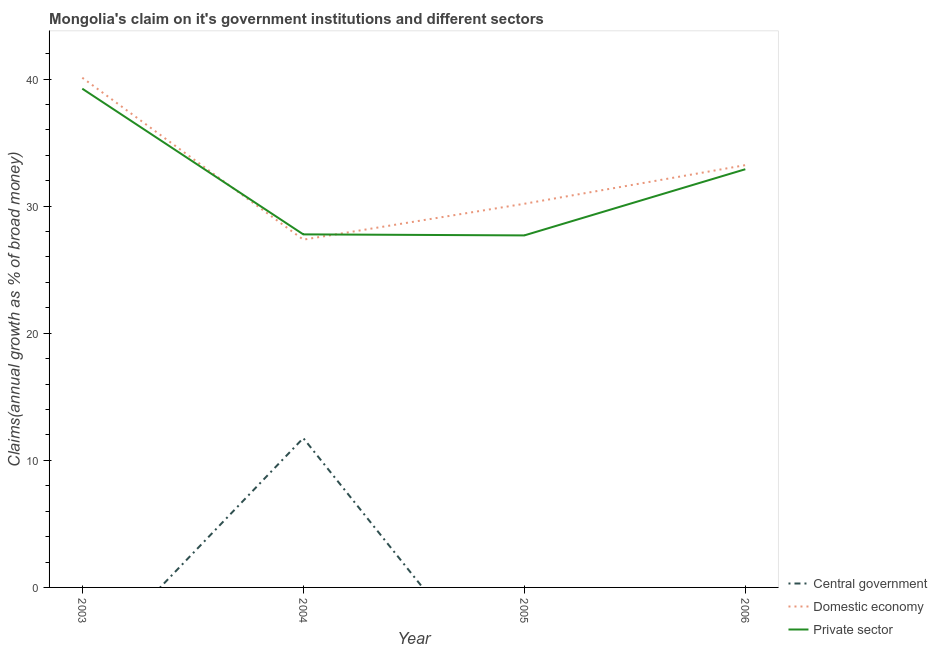Does the line corresponding to percentage of claim on the private sector intersect with the line corresponding to percentage of claim on the central government?
Offer a very short reply. No. What is the percentage of claim on the private sector in 2005?
Your response must be concise. 27.69. Across all years, what is the maximum percentage of claim on the central government?
Keep it short and to the point. 11.75. Across all years, what is the minimum percentage of claim on the private sector?
Give a very brief answer. 27.69. In which year was the percentage of claim on the private sector maximum?
Keep it short and to the point. 2003. What is the total percentage of claim on the private sector in the graph?
Offer a terse response. 127.61. What is the difference between the percentage of claim on the private sector in 2003 and that in 2006?
Provide a succinct answer. 6.34. What is the difference between the percentage of claim on the central government in 2004 and the percentage of claim on the domestic economy in 2003?
Make the answer very short. -28.35. What is the average percentage of claim on the central government per year?
Offer a very short reply. 2.94. In the year 2004, what is the difference between the percentage of claim on the domestic economy and percentage of claim on the private sector?
Your response must be concise. -0.41. In how many years, is the percentage of claim on the central government greater than 34 %?
Offer a terse response. 0. What is the ratio of the percentage of claim on the domestic economy in 2003 to that in 2006?
Your answer should be very brief. 1.21. What is the difference between the highest and the second highest percentage of claim on the private sector?
Your answer should be compact. 6.34. What is the difference between the highest and the lowest percentage of claim on the domestic economy?
Provide a succinct answer. 12.74. Is the percentage of claim on the domestic economy strictly greater than the percentage of claim on the private sector over the years?
Provide a succinct answer. No. Is the percentage of claim on the domestic economy strictly less than the percentage of claim on the private sector over the years?
Your response must be concise. No. How many lines are there?
Make the answer very short. 3. How many years are there in the graph?
Ensure brevity in your answer.  4. What is the difference between two consecutive major ticks on the Y-axis?
Your answer should be compact. 10. Does the graph contain any zero values?
Keep it short and to the point. Yes. Does the graph contain grids?
Keep it short and to the point. No. How are the legend labels stacked?
Give a very brief answer. Vertical. What is the title of the graph?
Ensure brevity in your answer.  Mongolia's claim on it's government institutions and different sectors. What is the label or title of the Y-axis?
Provide a succinct answer. Claims(annual growth as % of broad money). What is the Claims(annual growth as % of broad money) of Central government in 2003?
Your answer should be compact. 0. What is the Claims(annual growth as % of broad money) of Domestic economy in 2003?
Offer a terse response. 40.1. What is the Claims(annual growth as % of broad money) of Private sector in 2003?
Provide a short and direct response. 39.24. What is the Claims(annual growth as % of broad money) in Central government in 2004?
Keep it short and to the point. 11.75. What is the Claims(annual growth as % of broad money) of Domestic economy in 2004?
Ensure brevity in your answer.  27.36. What is the Claims(annual growth as % of broad money) in Private sector in 2004?
Provide a short and direct response. 27.78. What is the Claims(annual growth as % of broad money) in Central government in 2005?
Keep it short and to the point. 0. What is the Claims(annual growth as % of broad money) in Domestic economy in 2005?
Ensure brevity in your answer.  30.18. What is the Claims(annual growth as % of broad money) in Private sector in 2005?
Ensure brevity in your answer.  27.69. What is the Claims(annual growth as % of broad money) in Domestic economy in 2006?
Give a very brief answer. 33.22. What is the Claims(annual growth as % of broad money) of Private sector in 2006?
Offer a terse response. 32.9. Across all years, what is the maximum Claims(annual growth as % of broad money) in Central government?
Offer a terse response. 11.75. Across all years, what is the maximum Claims(annual growth as % of broad money) in Domestic economy?
Provide a succinct answer. 40.1. Across all years, what is the maximum Claims(annual growth as % of broad money) of Private sector?
Keep it short and to the point. 39.24. Across all years, what is the minimum Claims(annual growth as % of broad money) of Domestic economy?
Keep it short and to the point. 27.36. Across all years, what is the minimum Claims(annual growth as % of broad money) in Private sector?
Your response must be concise. 27.69. What is the total Claims(annual growth as % of broad money) in Central government in the graph?
Your response must be concise. 11.75. What is the total Claims(annual growth as % of broad money) of Domestic economy in the graph?
Keep it short and to the point. 130.87. What is the total Claims(annual growth as % of broad money) of Private sector in the graph?
Your answer should be compact. 127.61. What is the difference between the Claims(annual growth as % of broad money) of Domestic economy in 2003 and that in 2004?
Offer a terse response. 12.74. What is the difference between the Claims(annual growth as % of broad money) of Private sector in 2003 and that in 2004?
Your response must be concise. 11.46. What is the difference between the Claims(annual growth as % of broad money) of Domestic economy in 2003 and that in 2005?
Your response must be concise. 9.92. What is the difference between the Claims(annual growth as % of broad money) in Private sector in 2003 and that in 2005?
Provide a short and direct response. 11.54. What is the difference between the Claims(annual growth as % of broad money) in Domestic economy in 2003 and that in 2006?
Make the answer very short. 6.88. What is the difference between the Claims(annual growth as % of broad money) of Private sector in 2003 and that in 2006?
Offer a very short reply. 6.34. What is the difference between the Claims(annual growth as % of broad money) of Domestic economy in 2004 and that in 2005?
Provide a short and direct response. -2.82. What is the difference between the Claims(annual growth as % of broad money) in Private sector in 2004 and that in 2005?
Your answer should be compact. 0.08. What is the difference between the Claims(annual growth as % of broad money) of Domestic economy in 2004 and that in 2006?
Make the answer very short. -5.86. What is the difference between the Claims(annual growth as % of broad money) in Private sector in 2004 and that in 2006?
Give a very brief answer. -5.13. What is the difference between the Claims(annual growth as % of broad money) of Domestic economy in 2005 and that in 2006?
Your answer should be compact. -3.04. What is the difference between the Claims(annual growth as % of broad money) of Private sector in 2005 and that in 2006?
Your response must be concise. -5.21. What is the difference between the Claims(annual growth as % of broad money) in Domestic economy in 2003 and the Claims(annual growth as % of broad money) in Private sector in 2004?
Offer a very short reply. 12.32. What is the difference between the Claims(annual growth as % of broad money) of Domestic economy in 2003 and the Claims(annual growth as % of broad money) of Private sector in 2005?
Make the answer very short. 12.41. What is the difference between the Claims(annual growth as % of broad money) in Domestic economy in 2003 and the Claims(annual growth as % of broad money) in Private sector in 2006?
Offer a very short reply. 7.2. What is the difference between the Claims(annual growth as % of broad money) in Central government in 2004 and the Claims(annual growth as % of broad money) in Domestic economy in 2005?
Provide a short and direct response. -18.44. What is the difference between the Claims(annual growth as % of broad money) in Central government in 2004 and the Claims(annual growth as % of broad money) in Private sector in 2005?
Make the answer very short. -15.95. What is the difference between the Claims(annual growth as % of broad money) of Domestic economy in 2004 and the Claims(annual growth as % of broad money) of Private sector in 2005?
Give a very brief answer. -0.33. What is the difference between the Claims(annual growth as % of broad money) of Central government in 2004 and the Claims(annual growth as % of broad money) of Domestic economy in 2006?
Your response must be concise. -21.47. What is the difference between the Claims(annual growth as % of broad money) in Central government in 2004 and the Claims(annual growth as % of broad money) in Private sector in 2006?
Your answer should be compact. -21.15. What is the difference between the Claims(annual growth as % of broad money) in Domestic economy in 2004 and the Claims(annual growth as % of broad money) in Private sector in 2006?
Provide a short and direct response. -5.54. What is the difference between the Claims(annual growth as % of broad money) in Domestic economy in 2005 and the Claims(annual growth as % of broad money) in Private sector in 2006?
Ensure brevity in your answer.  -2.72. What is the average Claims(annual growth as % of broad money) of Central government per year?
Your answer should be compact. 2.94. What is the average Claims(annual growth as % of broad money) in Domestic economy per year?
Offer a very short reply. 32.72. What is the average Claims(annual growth as % of broad money) in Private sector per year?
Your response must be concise. 31.9. In the year 2003, what is the difference between the Claims(annual growth as % of broad money) of Domestic economy and Claims(annual growth as % of broad money) of Private sector?
Your response must be concise. 0.86. In the year 2004, what is the difference between the Claims(annual growth as % of broad money) in Central government and Claims(annual growth as % of broad money) in Domestic economy?
Provide a succinct answer. -15.61. In the year 2004, what is the difference between the Claims(annual growth as % of broad money) of Central government and Claims(annual growth as % of broad money) of Private sector?
Your answer should be compact. -16.03. In the year 2004, what is the difference between the Claims(annual growth as % of broad money) of Domestic economy and Claims(annual growth as % of broad money) of Private sector?
Ensure brevity in your answer.  -0.41. In the year 2005, what is the difference between the Claims(annual growth as % of broad money) of Domestic economy and Claims(annual growth as % of broad money) of Private sector?
Keep it short and to the point. 2.49. In the year 2006, what is the difference between the Claims(annual growth as % of broad money) of Domestic economy and Claims(annual growth as % of broad money) of Private sector?
Make the answer very short. 0.32. What is the ratio of the Claims(annual growth as % of broad money) of Domestic economy in 2003 to that in 2004?
Give a very brief answer. 1.47. What is the ratio of the Claims(annual growth as % of broad money) of Private sector in 2003 to that in 2004?
Your response must be concise. 1.41. What is the ratio of the Claims(annual growth as % of broad money) in Domestic economy in 2003 to that in 2005?
Your answer should be compact. 1.33. What is the ratio of the Claims(annual growth as % of broad money) of Private sector in 2003 to that in 2005?
Give a very brief answer. 1.42. What is the ratio of the Claims(annual growth as % of broad money) of Domestic economy in 2003 to that in 2006?
Provide a short and direct response. 1.21. What is the ratio of the Claims(annual growth as % of broad money) in Private sector in 2003 to that in 2006?
Make the answer very short. 1.19. What is the ratio of the Claims(annual growth as % of broad money) in Domestic economy in 2004 to that in 2005?
Your response must be concise. 0.91. What is the ratio of the Claims(annual growth as % of broad money) of Private sector in 2004 to that in 2005?
Provide a short and direct response. 1. What is the ratio of the Claims(annual growth as % of broad money) in Domestic economy in 2004 to that in 2006?
Make the answer very short. 0.82. What is the ratio of the Claims(annual growth as % of broad money) of Private sector in 2004 to that in 2006?
Provide a succinct answer. 0.84. What is the ratio of the Claims(annual growth as % of broad money) of Domestic economy in 2005 to that in 2006?
Offer a terse response. 0.91. What is the ratio of the Claims(annual growth as % of broad money) in Private sector in 2005 to that in 2006?
Your response must be concise. 0.84. What is the difference between the highest and the second highest Claims(annual growth as % of broad money) of Domestic economy?
Your answer should be compact. 6.88. What is the difference between the highest and the second highest Claims(annual growth as % of broad money) in Private sector?
Your answer should be compact. 6.34. What is the difference between the highest and the lowest Claims(annual growth as % of broad money) in Central government?
Ensure brevity in your answer.  11.75. What is the difference between the highest and the lowest Claims(annual growth as % of broad money) of Domestic economy?
Ensure brevity in your answer.  12.74. What is the difference between the highest and the lowest Claims(annual growth as % of broad money) in Private sector?
Your response must be concise. 11.54. 